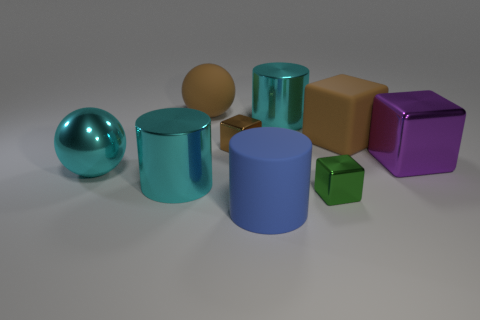Which objects in the image have a glossy surface? The sphere and both cylindrical objects have a glossy surface that reflects light, giving them a shiny appearance. 